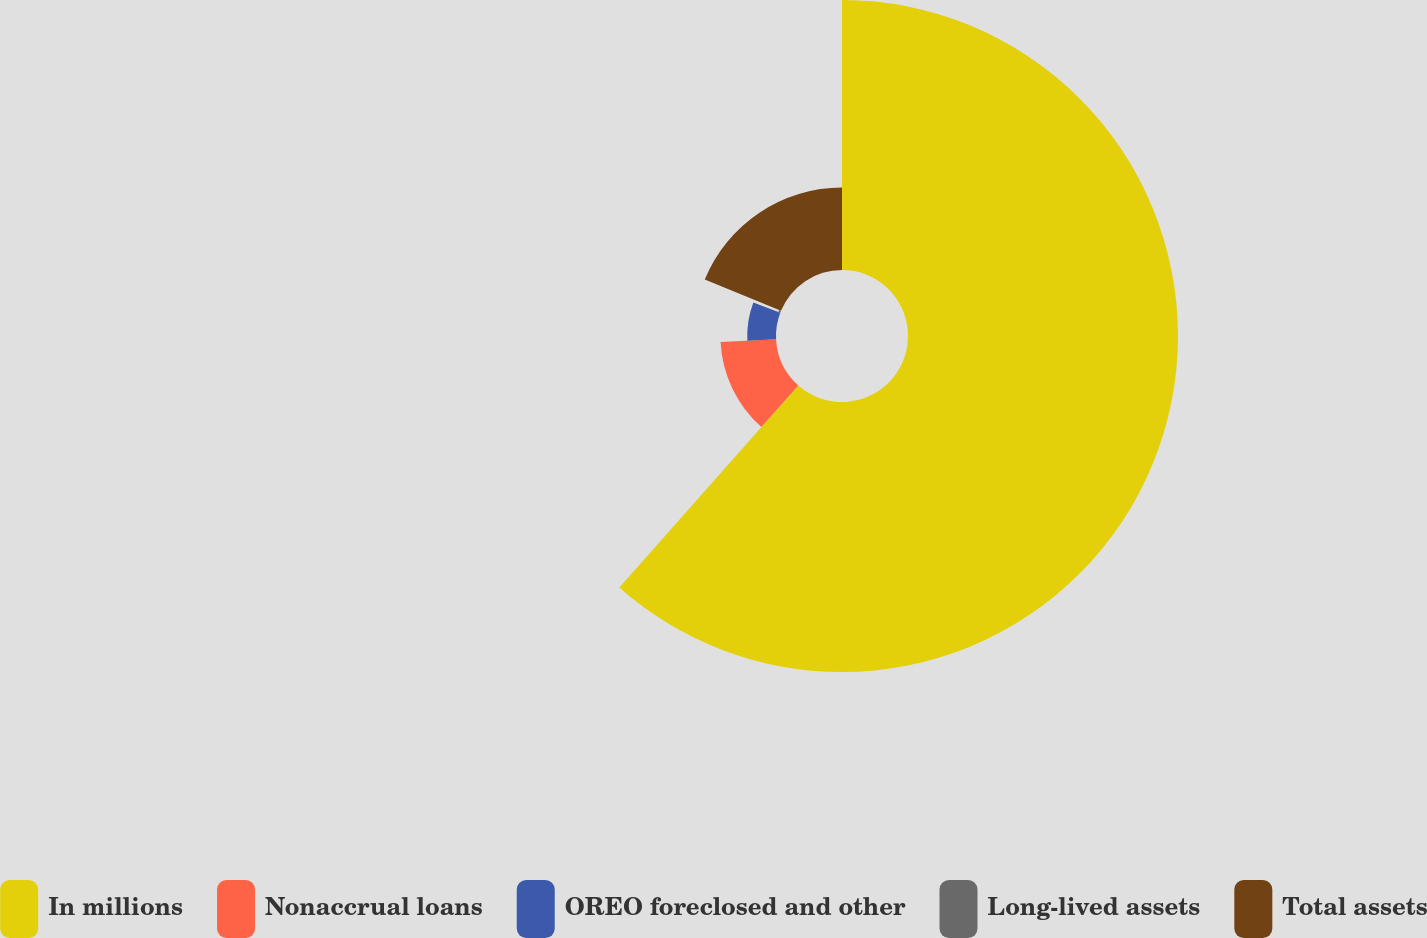Convert chart. <chart><loc_0><loc_0><loc_500><loc_500><pie_chart><fcel>In millions<fcel>Nonaccrual loans<fcel>OREO foreclosed and other<fcel>Long-lived assets<fcel>Total assets<nl><fcel>61.53%<fcel>12.67%<fcel>6.56%<fcel>0.46%<fcel>18.78%<nl></chart> 